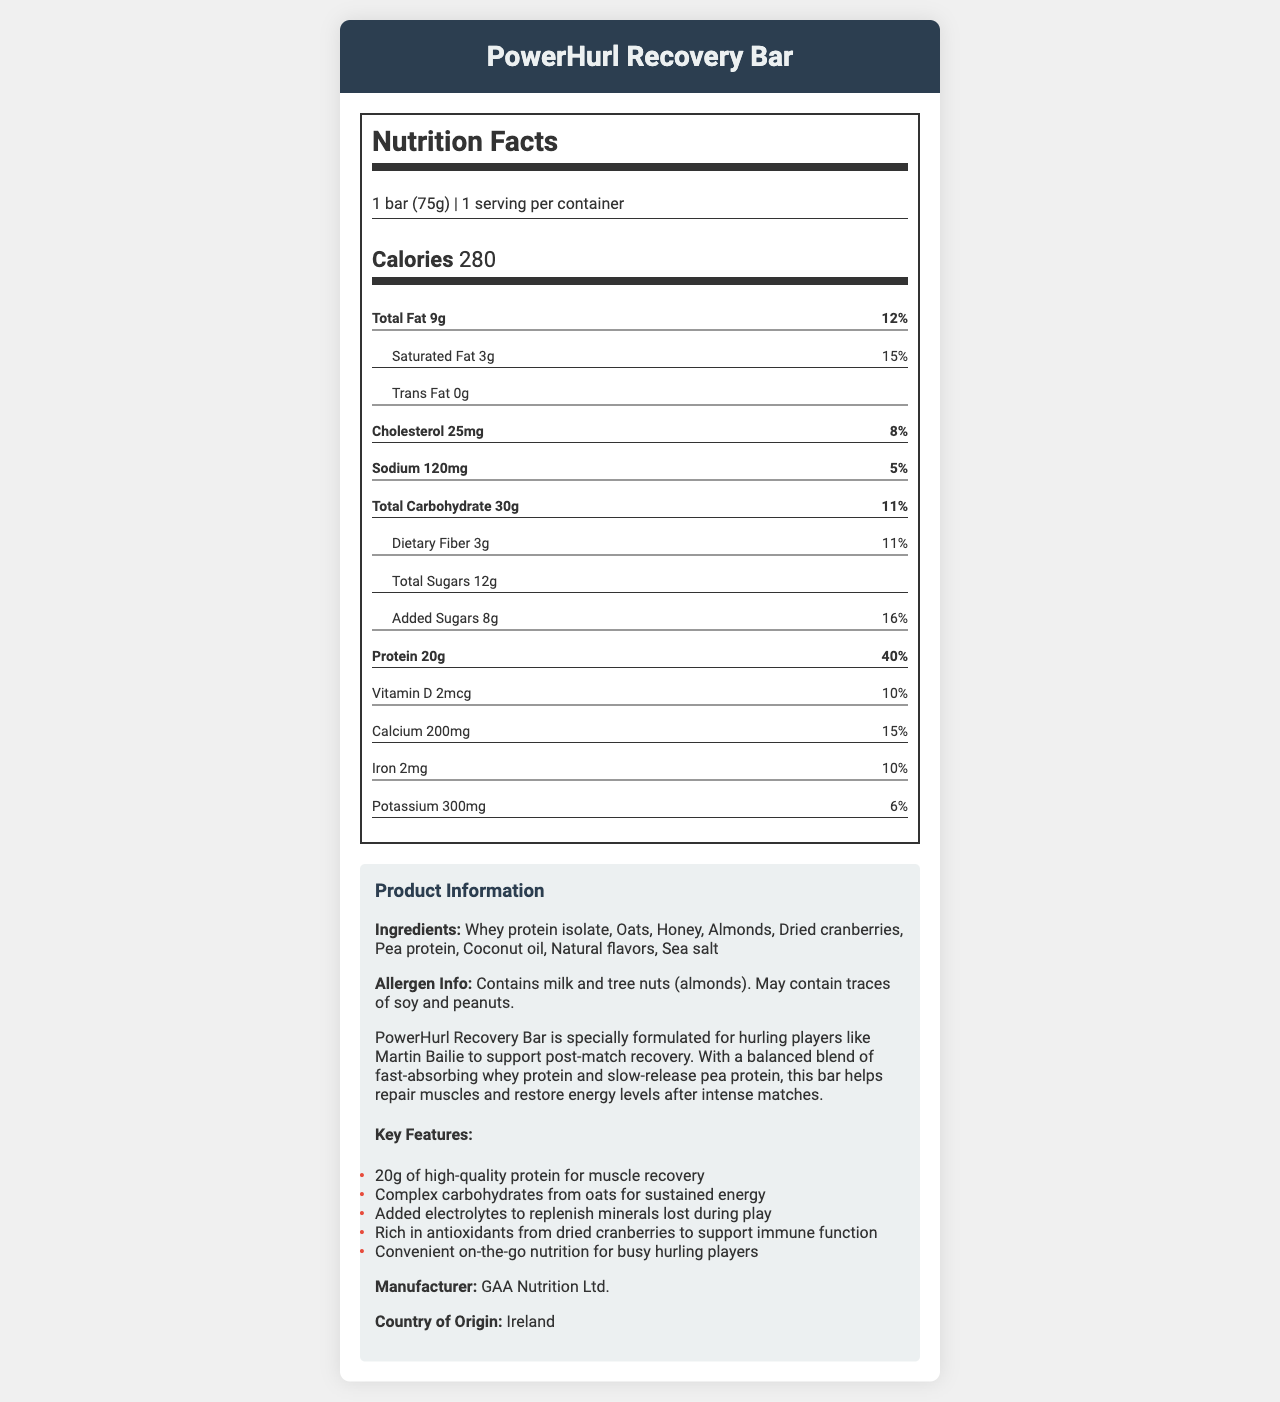what is the serving size of the PowerHurl Recovery Bar? The serving size is listed at the top of the Nutrition Facts label as "1 bar (75g)".
Answer: 1 bar (75g) How many calories does one serving of the PowerHurl Recovery Bar contain? The number of calories per serving is displayed under the calories section on the Nutrition Facts label.
Answer: 280 What is the protein content of the PowerHurl Recovery Bar? The protein content is listed in the Nutrition Facts under the "Protein" section as "20g".
Answer: 20g Which ingredients in the PowerHurl Recovery Bar might cause allergies? This information is found in the allergen info section, which states that the bar contains milk and tree nuts (almonds).
Answer: Milk and tree nuts (almonds) What is the daily value percentage of calcium per serving of the PowerHurl Recovery Bar? The daily value percentage for calcium is noted in the Nutrition Facts label under "Calcium" as "15%".
Answer: 15% How much total fat is in the PowerHurl Recovery Bar? The total fat content is listed in the Nutrition Facts label as "Total Fat 9g".
Answer: 9g What type of protein does the PowerHurl Recovery Bar contain? The ingredients list mentions "Whey protein isolate" and "Pea protein".
Answer: Whey protein isolate and pea protein Why is the PowerHurl Recovery Bar beneficial for hurling players? The product description and key features outline the benefits specifically tailored for hurling players: muscle recovery, energy, mineral replenishment, and immune support.
Answer: It supports muscle recovery, provides sustained energy, replenishes minerals, and supports immune function. Where is the PowerHurl Recovery Bar manufactured? The manufacturer and country of origin sections list "GAA Nutrition Ltd." and "Ireland".
Answer: Ireland What is the amount of dietary fiber in the PowerHurl Recovery Bar? The dietary fiber amount is shown in the Nutrition Facts as "Dietary Fiber 3g".
Answer: 3g Does the PowerHurl Recovery Bar contain any trans fats? The Nutrition Facts label lists "Trans Fat 0g", indicating there are no trans fats.
Answer: No Which of the following vitamins and minerals does the PowerHurl Recovery Bar provide? A. Vitamin D, Calcium, Iron, Potassium B. Vitamin C, Magnesium, Zinc, Sodium C. Vitamin A, Phosphorus, Copper, Manganese The Nutrition Facts label lists Vitamin D, Calcium, Iron, and Potassium as the included vitamins and minerals.
Answer: A What is the total amount of carbohydrates in the PowerHurl Recovery Bar? The Nutrition Facts label indicates the total carbohydrate content as "Total Carbohydrate 30g".
Answer: 30g How much sodium does one bar contain? The sodium content is listed in the Nutrition Facts as "Sodium 120mg".
Answer: 120mg Which of the following statements is true about the PowerHurl Recovery Bar? A. It contains 25mg of cholesterol B. It has 10% of the daily value of Vitamin C C. It provides 8g of total sugars The Nutrition Facts label mentions "Cholesterol 25mg", and it does not mention Vitamin C or 8g of total sugars.
Answer: A. It contains 25mg of cholesterol Summarize the key features and nutritional information of the PowerHurl Recovery Bar. The document contains detailed nutrition facts, key features, allergen information, and a description of the product's benefits geared towards hurling players. Key ingredients include whey protein isolate, oats, honey, and almonds.
Answer: The PowerHurl Recovery Bar provides 280 calories per 75g serving, containing 20g of protein, 9g of total fat, and 30g of carbohydrates. It has added electrolytes, dietary fiber (3g), and vitamins and minerals including Vitamin D, Calcium, Iron, and Potassium. It supports muscle recovery, immune function, and provides sustained energy, beneficial for hurling players post-match. What flavor is the PowerHurl Recovery Bar? The document does not provide any information about the specific flavor of the PowerHurl Recovery Bar.
Answer: Cannot be determined 